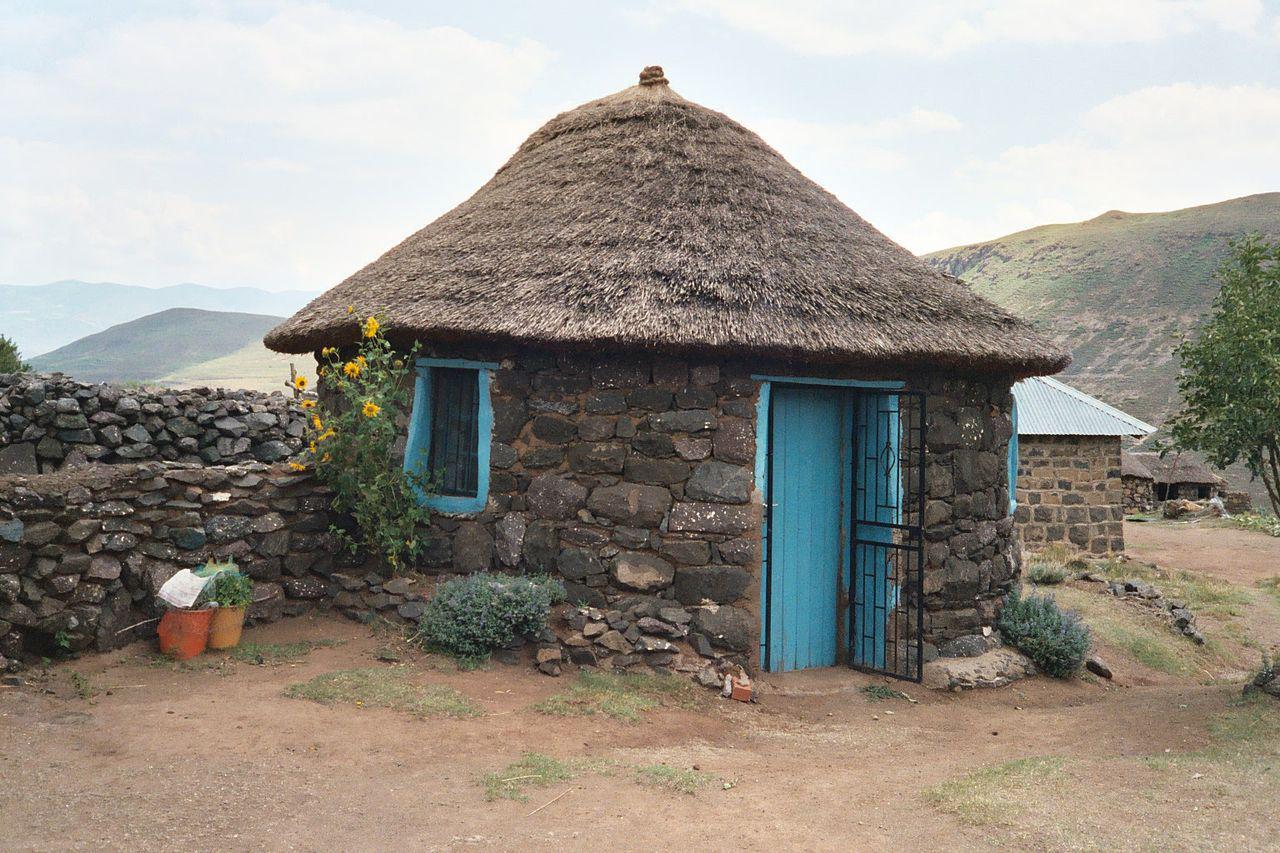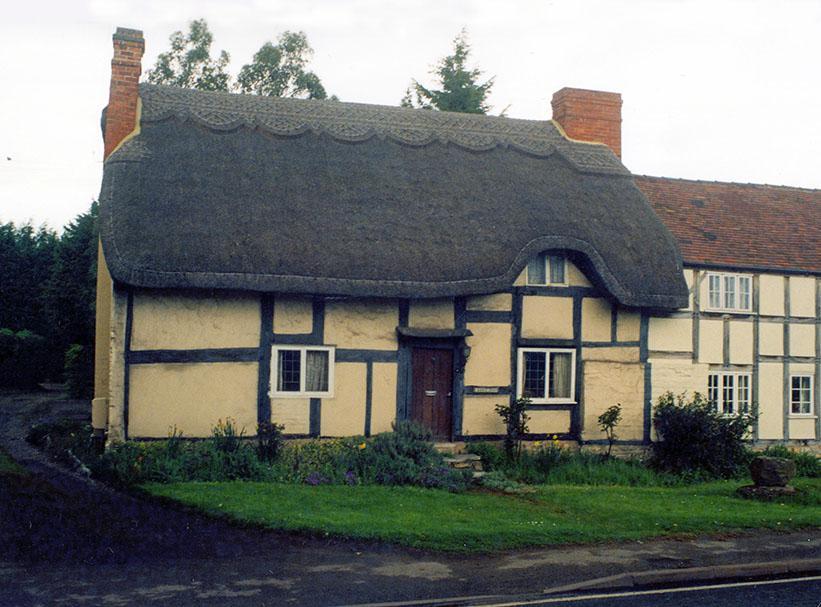The first image is the image on the left, the second image is the image on the right. For the images displayed, is the sentence "In at least one image there is a house with exposed wood planks about a white front door." factually correct? Answer yes or no. No. 